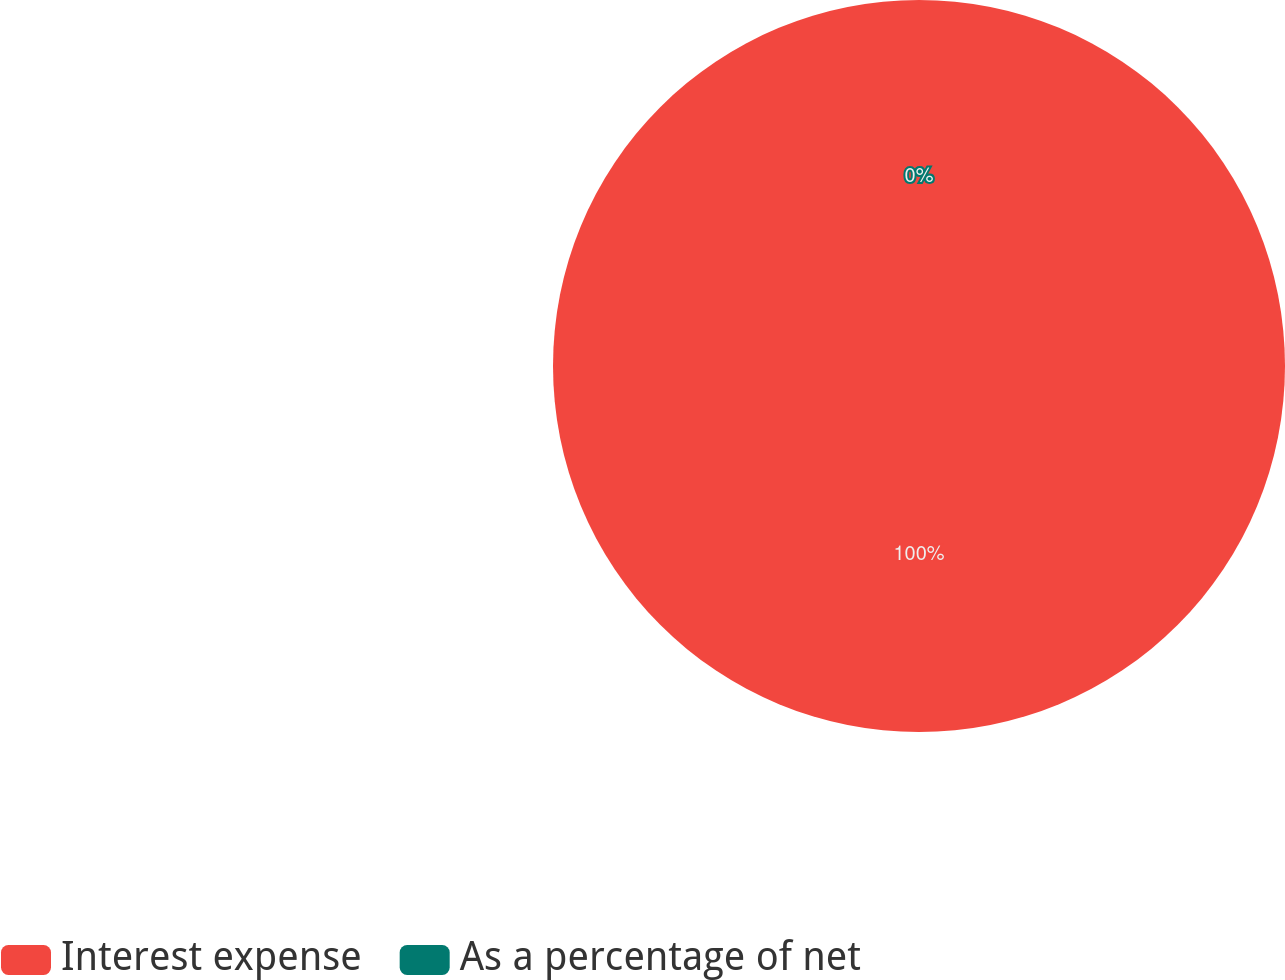Convert chart to OTSL. <chart><loc_0><loc_0><loc_500><loc_500><pie_chart><fcel>Interest expense<fcel>As a percentage of net<nl><fcel>100.0%<fcel>0.0%<nl></chart> 